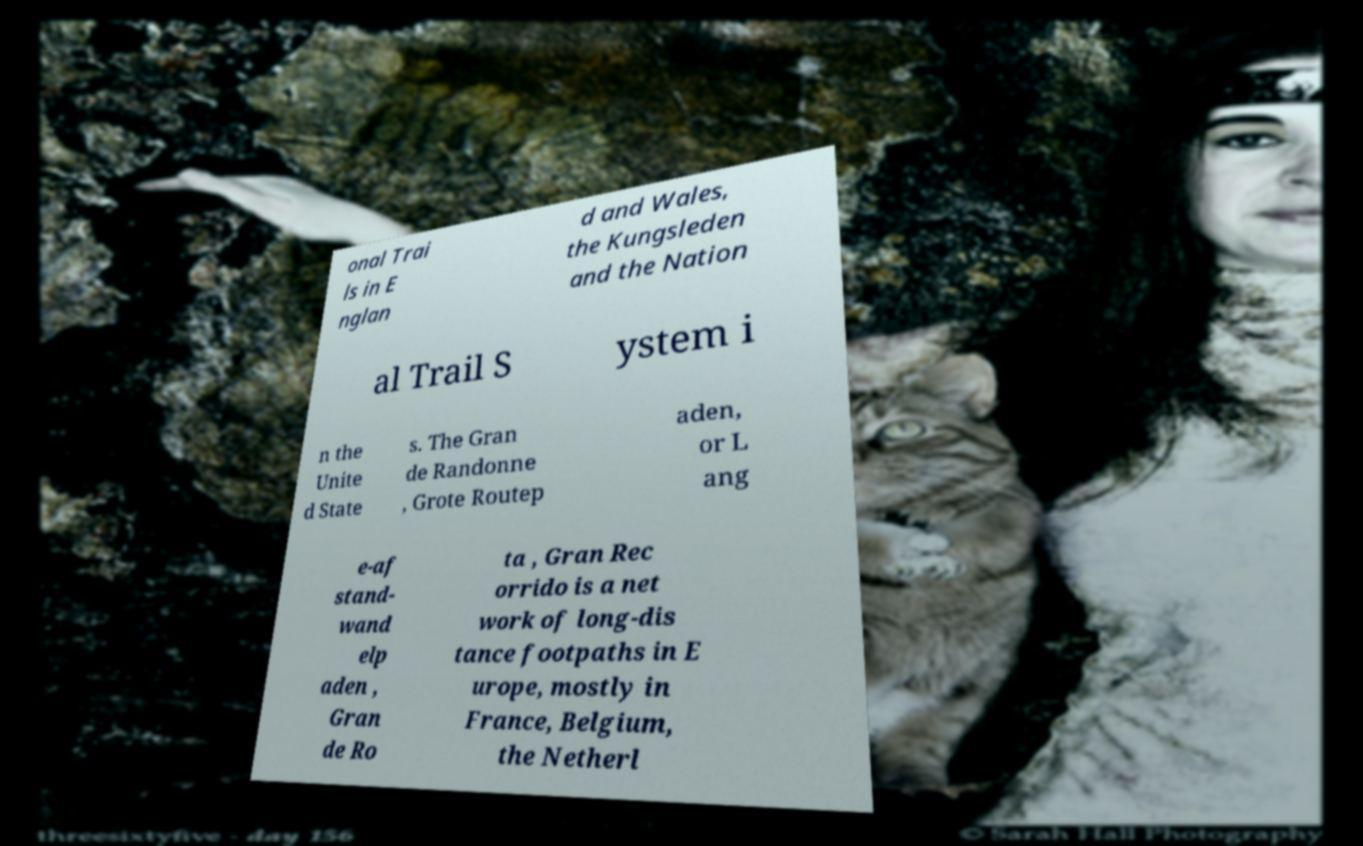There's text embedded in this image that I need extracted. Can you transcribe it verbatim? onal Trai ls in E nglan d and Wales, the Kungsleden and the Nation al Trail S ystem i n the Unite d State s. The Gran de Randonne , Grote Routep aden, or L ang e-af stand- wand elp aden , Gran de Ro ta , Gran Rec orrido is a net work of long-dis tance footpaths in E urope, mostly in France, Belgium, the Netherl 